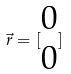Convert formula to latex. <formula><loc_0><loc_0><loc_500><loc_500>\vec { r } = [ \begin{matrix} 0 \\ 0 \end{matrix} ]</formula> 